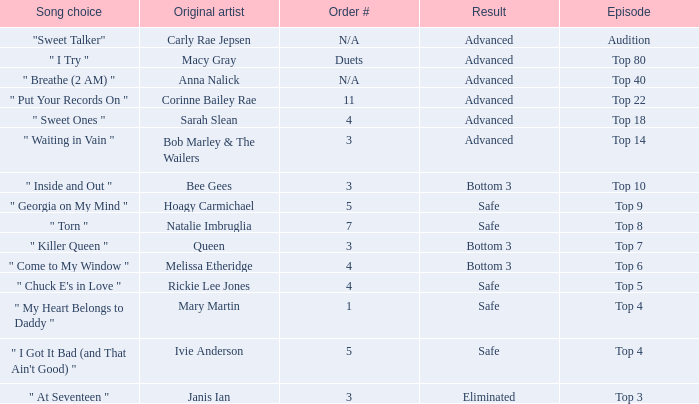What was the result of the Top 3 episode? Eliminated. 